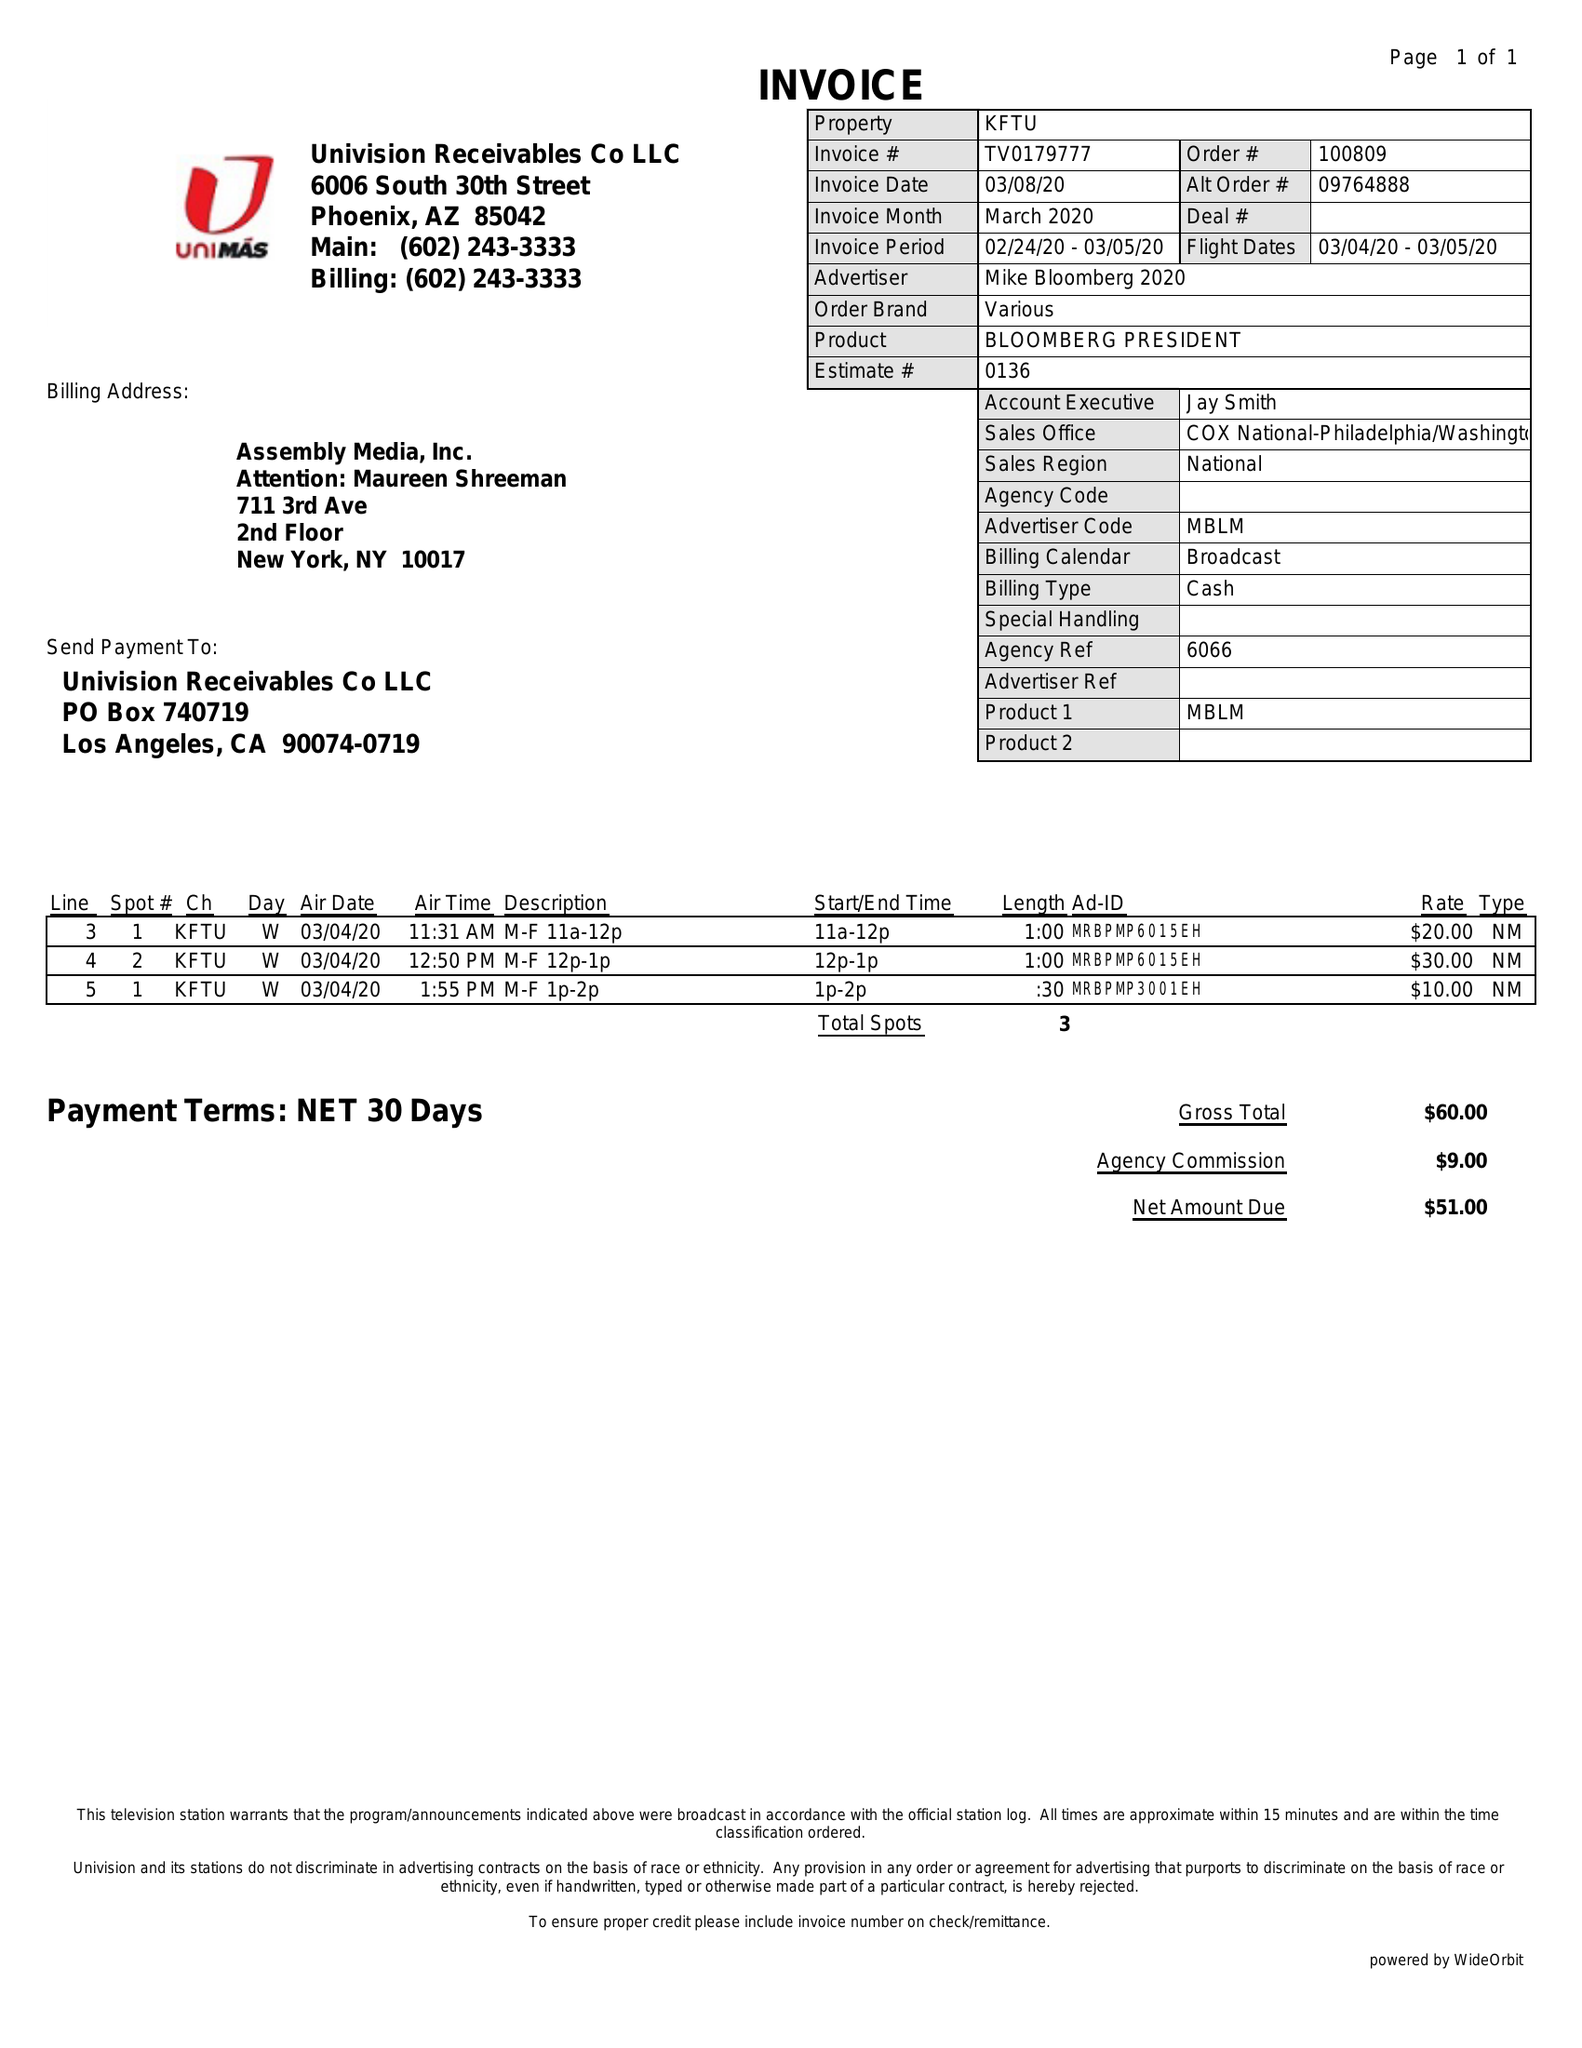What is the value for the advertiser?
Answer the question using a single word or phrase. MIKE BLOOMBERG 2020 